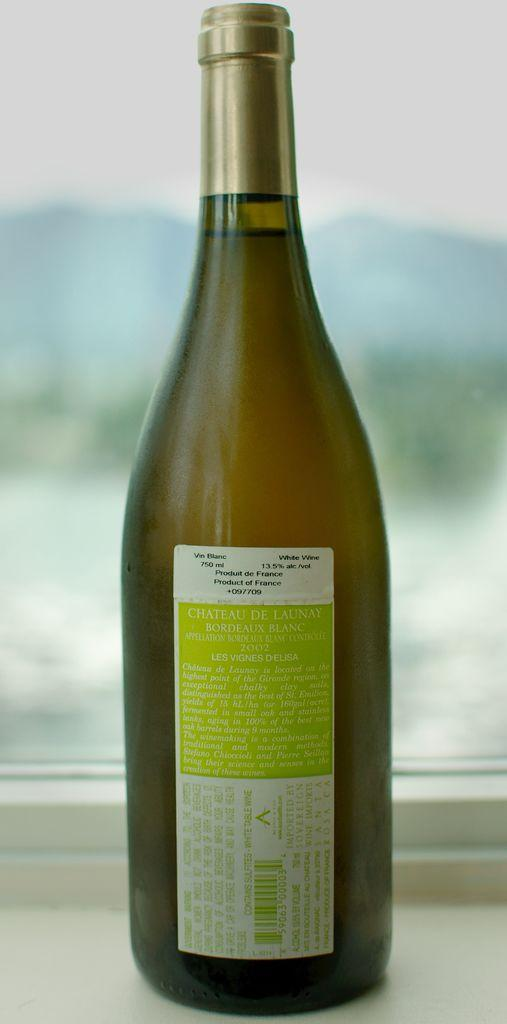What object can be seen in the image? There is a bottle in the image. What is the color of the bottle? The bottle is brown in color. Is there anything else on the bottle besides its color? Yes, there is a sticker on the bottle. What can be found on the sticker? The sticker has many words on it. What type of canvas is visible in the image? There is no canvas present in the image. 